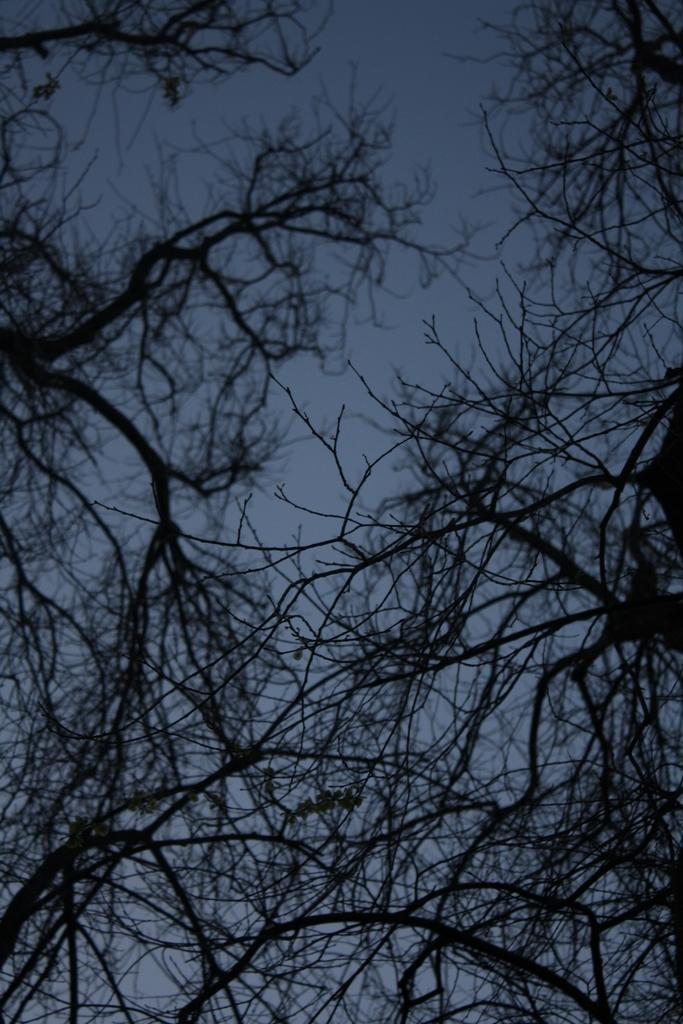What type of vegetation can be seen in the image? There are trees in the image. What part of the natural environment is visible in the image? The sky is visible in the image. What type of weather is indicated by the presence of sleet in the image? There is no mention of sleet in the image; it only shows trees and the sky. How does the wind blow the trees in the image? The image does not depict any wind blowing the trees; they are stationary. 